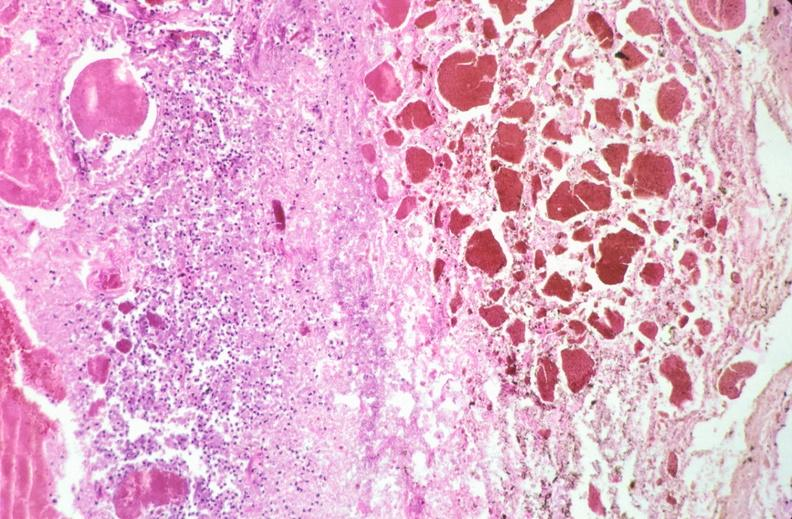what ingested as suicide attempt?
Answer the question using a single word or phrase. Stomach, necrotizing esophagitis and gastritis, sulfuric acid 